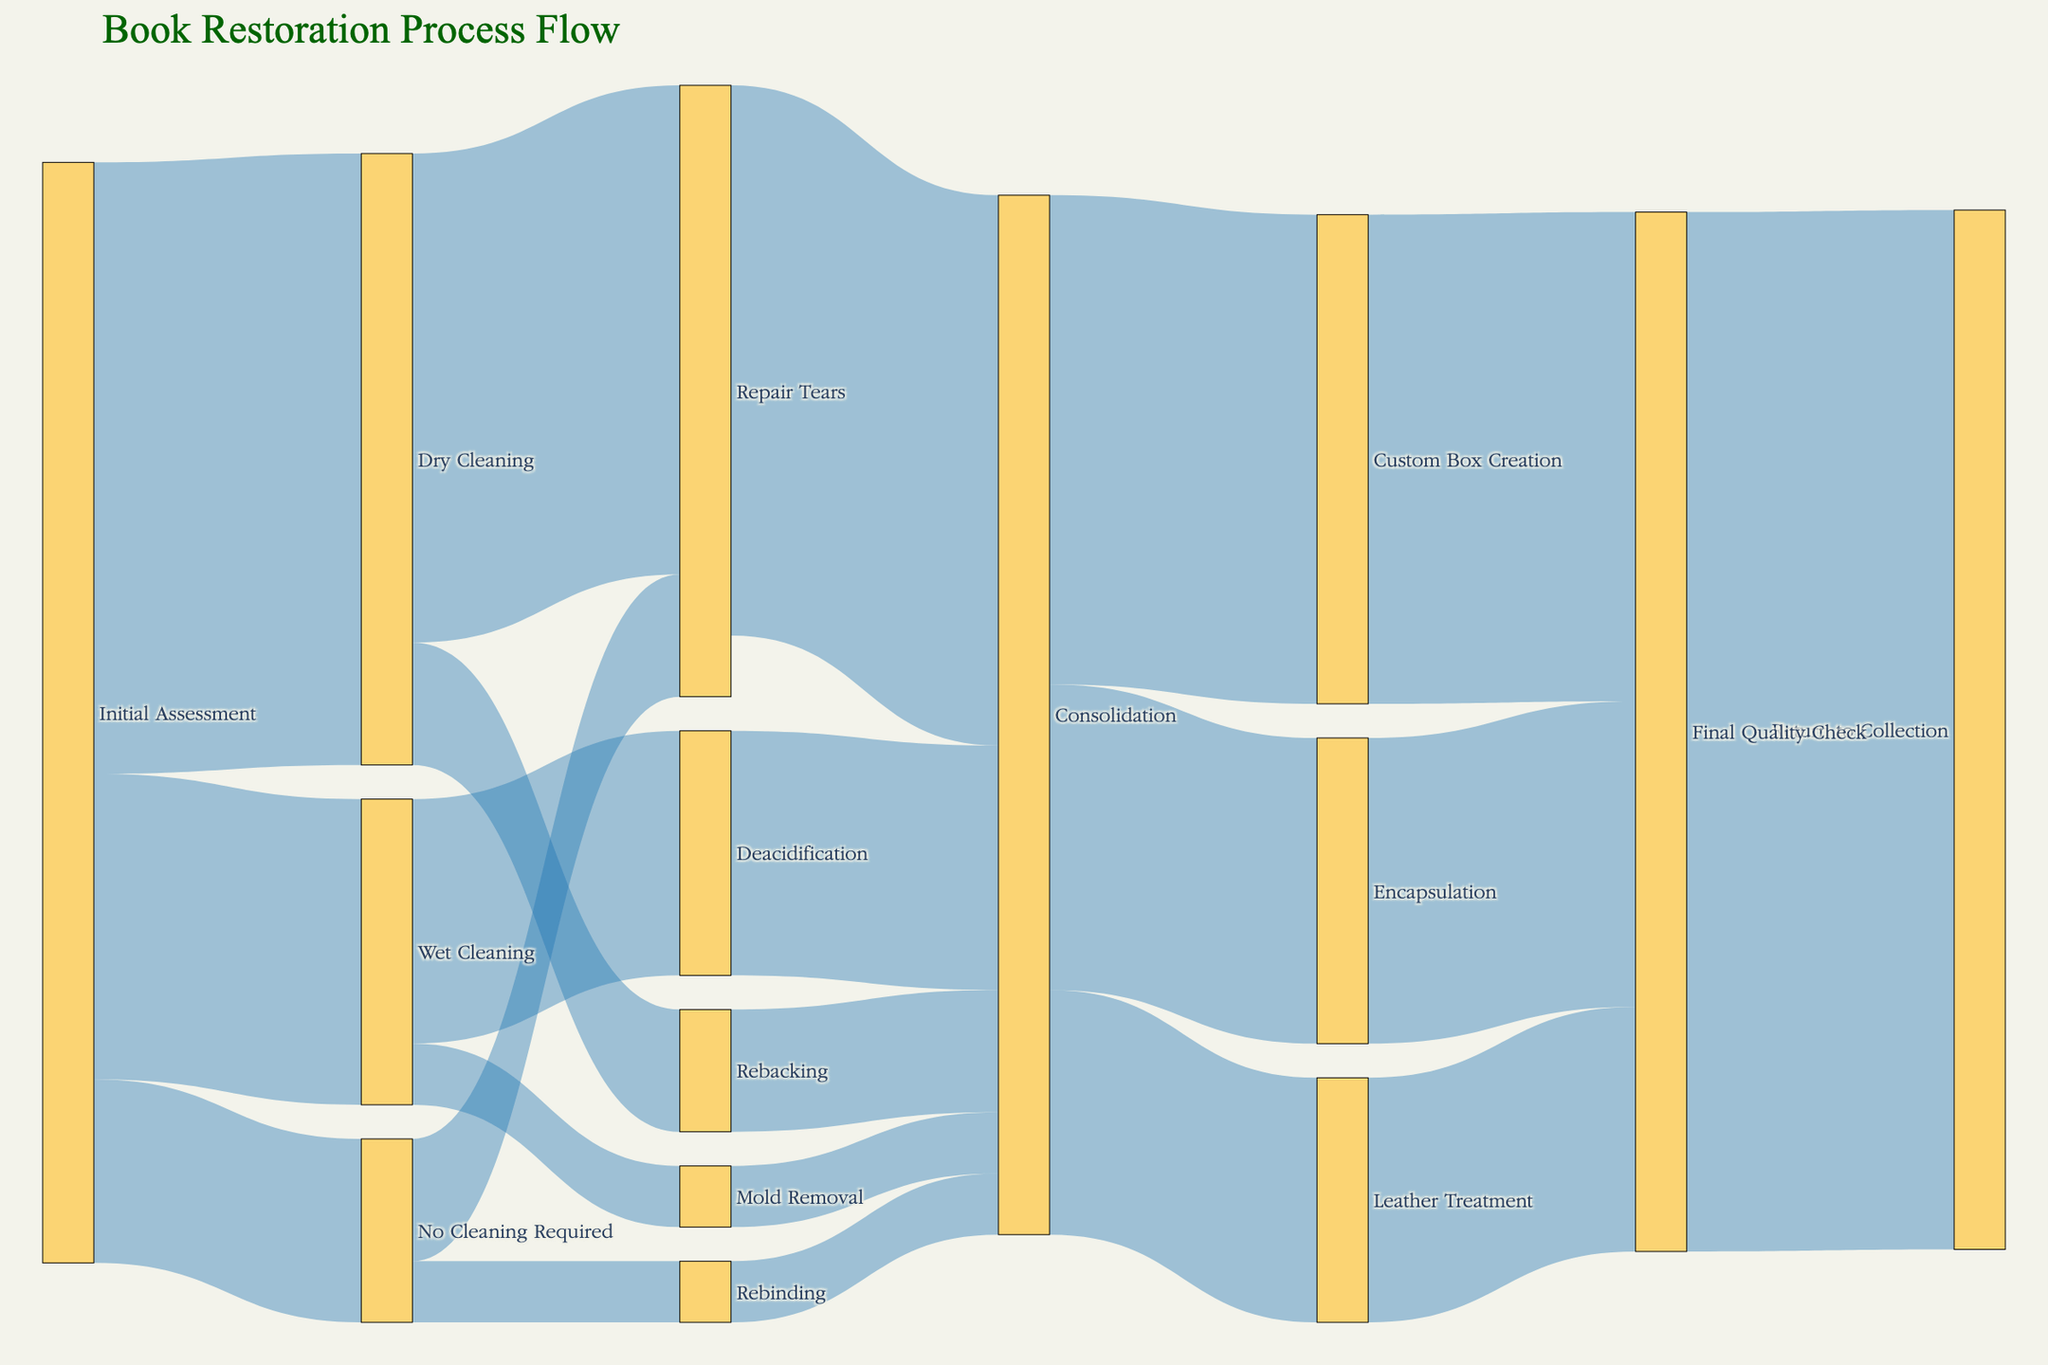What's the title of the Sankey Diagram? The title of a chart is generally positioned at or near the top and is often formatted to stand out. In this case, the title appears in large text.
Answer: "Book Restoration Process Flow" How many nodes does the diagram have? To determine the number of nodes, count all the unique items in both the 'source' and 'target' columns. Each unique item represents a node.
Answer: 14 What process follows "Initial Assessment" the most? To find the process that follows "Initial Assessment" most frequently, look at the values associated with each of its outgoing paths and identify the highest one. "Dry Cleaning" has the highest value of 100.
Answer: "Dry Cleaning" How many items are returned to the collection after the final quality check? Trace all paths leading to the "Return to Collection" node from the "Final Quality Check" node and sum up their values. The values are 50 (from Encapsulation), 80 (from Custom Box Creation), and 40 (from Leather Treatment), totaling 170.
Answer: 170 What is the combined value of books undergoing "Wet Cleaning"? Sum up the values of all paths originating from "Wet Cleaning". These values are 40 (to Deacidification) and 10 (to Mold Removal), resulting in a total of 50.
Answer: 50 Which cleaning method leads to "Repair Tears", and how many books go through this process? Identify the path leading to "Repair Tears" from a cleaning method. In this case, it is "Dry Cleaning" leading to 80 books being processed for "Repair Tears".
Answer: "Dry Cleaning", 80 What's the proportion of books requiring "Leather Treatment" compared to total books undergoing "Final Quality Check"? First, determine the number of books going through "Leather Treatment" (40). Then, determine the total books undergoing "Final Quality Check" by summing values from all preceding nodes: 50 (Encapsulation), 80 (Custom Box Creation), and 40 (Leather Treatment). These add up to 170. The proportion is 40/170.
Answer: 40/170 Which process has the least number of books following "Initial Assessment"? Compare values leading from "Initial Assessment" to different targets: "Dry Cleaning" (100), "Wet Cleaning" (50), and "No Cleaning Required" (30). "No Cleaning Required" has the least number of books.
Answer: "No Cleaning Required" Do more books go through "Deacidification" or "Rebacking"? Compare the values of books undergoing "Deacidification" (40) and "Rebacking" (20).
Answer: "Deacidification" What steps do books that need "Encapsulation" go through before reaching this process? Trace the paths backwards from "Encapsulation". They are: 50 from "Consolidation" with inputs from "Repair Tears" (80 => 90), "Rebacking" (20), "Mold Removal" (10), "Deacidification" (40), and "Rebinding" (10).
Answer: "Repair Tears", "Rebacking", "Mold Removal", "Deacidification", "Rebinding" 